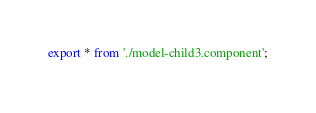Convert code to text. <code><loc_0><loc_0><loc_500><loc_500><_TypeScript_>export * from './model-child3.component';
</code> 